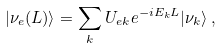Convert formula to latex. <formula><loc_0><loc_0><loc_500><loc_500>| \nu _ { e } ( L ) \rangle = \sum _ { k } U _ { e k } e ^ { - i E _ { k } L } | \nu _ { k } \rangle \, ,</formula> 